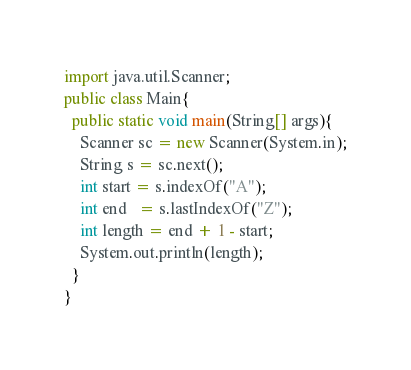<code> <loc_0><loc_0><loc_500><loc_500><_Java_>import java.util.Scanner;
public class Main{
  public static void main(String[] args){
	Scanner sc = new Scanner(System.in);
    String s = sc.next();
    int start = s.indexOf("A");
    int end   = s.lastIndexOf("Z");
    int length = end + 1 - start;
    System.out.println(length);    
  }
}


</code> 